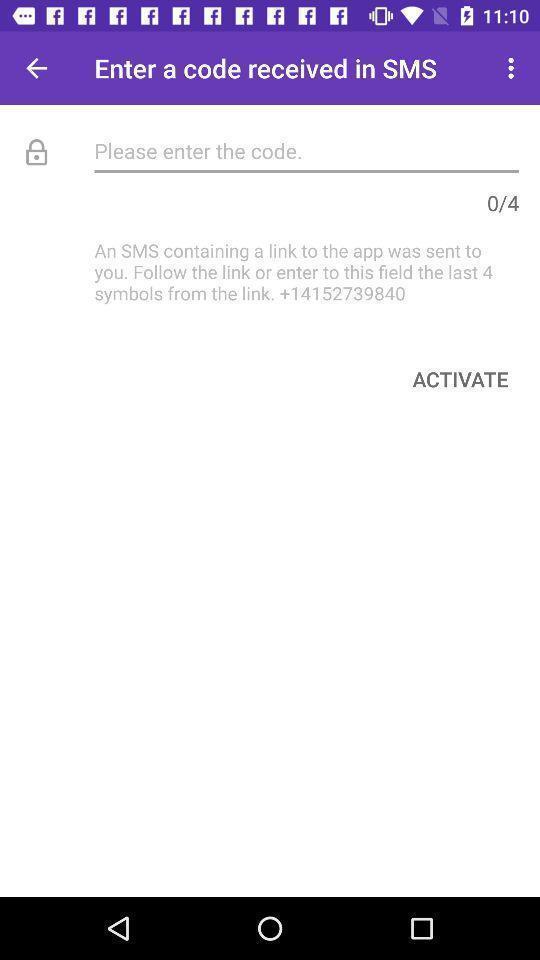Tell me what you see in this picture. Screen displaying contents in verification page. 